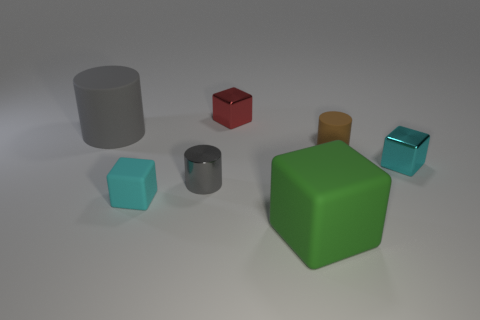Does the big rubber object to the left of the cyan matte thing have the same color as the tiny cylinder that is on the left side of the big green block?
Your response must be concise. Yes. Are there more large things behind the brown object than big green things that are left of the red metallic object?
Offer a very short reply. Yes. What is the shape of the cyan thing that is made of the same material as the green block?
Provide a short and direct response. Cube. Are there more small rubber cylinders to the right of the gray metallic thing than big red metallic things?
Offer a very short reply. Yes. How many blocks are the same color as the large matte cylinder?
Keep it short and to the point. 0. How many other things are there of the same color as the tiny metallic cylinder?
Your answer should be compact. 1. Is the number of red cylinders greater than the number of gray shiny cylinders?
Your response must be concise. No. What is the green object made of?
Provide a short and direct response. Rubber. There is a matte cylinder in front of the gray rubber thing; is its size the same as the large gray rubber cylinder?
Provide a short and direct response. No. There is a cyan cube to the right of the cyan matte object; how big is it?
Offer a terse response. Small. 